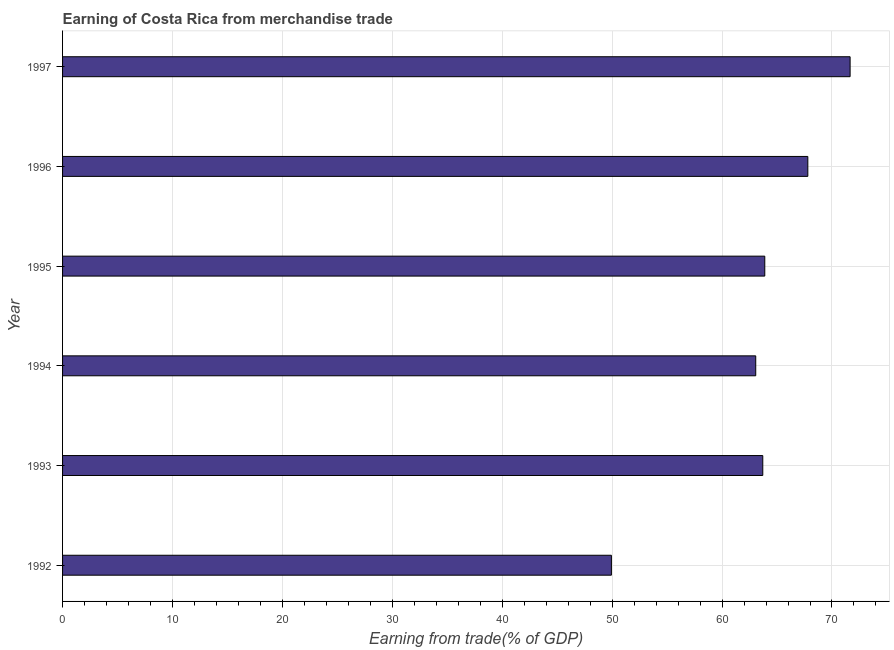Does the graph contain grids?
Keep it short and to the point. Yes. What is the title of the graph?
Keep it short and to the point. Earning of Costa Rica from merchandise trade. What is the label or title of the X-axis?
Provide a short and direct response. Earning from trade(% of GDP). What is the label or title of the Y-axis?
Keep it short and to the point. Year. What is the earning from merchandise trade in 1994?
Offer a terse response. 63.06. Across all years, what is the maximum earning from merchandise trade?
Keep it short and to the point. 71.65. Across all years, what is the minimum earning from merchandise trade?
Offer a very short reply. 49.93. In which year was the earning from merchandise trade maximum?
Keep it short and to the point. 1997. In which year was the earning from merchandise trade minimum?
Give a very brief answer. 1992. What is the sum of the earning from merchandise trade?
Provide a short and direct response. 380.04. What is the difference between the earning from merchandise trade in 1993 and 1997?
Make the answer very short. -7.95. What is the average earning from merchandise trade per year?
Your answer should be very brief. 63.34. What is the median earning from merchandise trade?
Provide a succinct answer. 63.8. In how many years, is the earning from merchandise trade greater than 18 %?
Your answer should be compact. 6. What is the ratio of the earning from merchandise trade in 1996 to that in 1997?
Your answer should be compact. 0.95. Is the earning from merchandise trade in 1994 less than that in 1995?
Provide a short and direct response. Yes. Is the difference between the earning from merchandise trade in 1993 and 1995 greater than the difference between any two years?
Your response must be concise. No. What is the difference between the highest and the second highest earning from merchandise trade?
Offer a very short reply. 3.85. What is the difference between the highest and the lowest earning from merchandise trade?
Offer a terse response. 21.72. How many bars are there?
Make the answer very short. 6. Are all the bars in the graph horizontal?
Make the answer very short. Yes. How many years are there in the graph?
Provide a short and direct response. 6. What is the Earning from trade(% of GDP) of 1992?
Offer a terse response. 49.93. What is the Earning from trade(% of GDP) of 1993?
Keep it short and to the point. 63.7. What is the Earning from trade(% of GDP) in 1994?
Provide a short and direct response. 63.06. What is the Earning from trade(% of GDP) in 1995?
Your answer should be compact. 63.89. What is the Earning from trade(% of GDP) of 1996?
Your response must be concise. 67.8. What is the Earning from trade(% of GDP) in 1997?
Make the answer very short. 71.65. What is the difference between the Earning from trade(% of GDP) in 1992 and 1993?
Make the answer very short. -13.77. What is the difference between the Earning from trade(% of GDP) in 1992 and 1994?
Make the answer very short. -13.13. What is the difference between the Earning from trade(% of GDP) in 1992 and 1995?
Your response must be concise. -13.95. What is the difference between the Earning from trade(% of GDP) in 1992 and 1996?
Your answer should be compact. -17.87. What is the difference between the Earning from trade(% of GDP) in 1992 and 1997?
Provide a succinct answer. -21.72. What is the difference between the Earning from trade(% of GDP) in 1993 and 1994?
Your answer should be very brief. 0.64. What is the difference between the Earning from trade(% of GDP) in 1993 and 1995?
Give a very brief answer. -0.18. What is the difference between the Earning from trade(% of GDP) in 1993 and 1996?
Offer a very short reply. -4.1. What is the difference between the Earning from trade(% of GDP) in 1993 and 1997?
Make the answer very short. -7.95. What is the difference between the Earning from trade(% of GDP) in 1994 and 1995?
Ensure brevity in your answer.  -0.82. What is the difference between the Earning from trade(% of GDP) in 1994 and 1996?
Make the answer very short. -4.74. What is the difference between the Earning from trade(% of GDP) in 1994 and 1997?
Provide a short and direct response. -8.59. What is the difference between the Earning from trade(% of GDP) in 1995 and 1996?
Keep it short and to the point. -3.92. What is the difference between the Earning from trade(% of GDP) in 1995 and 1997?
Keep it short and to the point. -7.76. What is the difference between the Earning from trade(% of GDP) in 1996 and 1997?
Give a very brief answer. -3.85. What is the ratio of the Earning from trade(% of GDP) in 1992 to that in 1993?
Provide a short and direct response. 0.78. What is the ratio of the Earning from trade(% of GDP) in 1992 to that in 1994?
Ensure brevity in your answer.  0.79. What is the ratio of the Earning from trade(% of GDP) in 1992 to that in 1995?
Make the answer very short. 0.78. What is the ratio of the Earning from trade(% of GDP) in 1992 to that in 1996?
Offer a terse response. 0.74. What is the ratio of the Earning from trade(% of GDP) in 1992 to that in 1997?
Offer a terse response. 0.7. What is the ratio of the Earning from trade(% of GDP) in 1993 to that in 1994?
Your answer should be compact. 1.01. What is the ratio of the Earning from trade(% of GDP) in 1993 to that in 1996?
Provide a short and direct response. 0.94. What is the ratio of the Earning from trade(% of GDP) in 1993 to that in 1997?
Ensure brevity in your answer.  0.89. What is the ratio of the Earning from trade(% of GDP) in 1994 to that in 1996?
Give a very brief answer. 0.93. What is the ratio of the Earning from trade(% of GDP) in 1995 to that in 1996?
Your answer should be compact. 0.94. What is the ratio of the Earning from trade(% of GDP) in 1995 to that in 1997?
Offer a very short reply. 0.89. What is the ratio of the Earning from trade(% of GDP) in 1996 to that in 1997?
Provide a short and direct response. 0.95. 